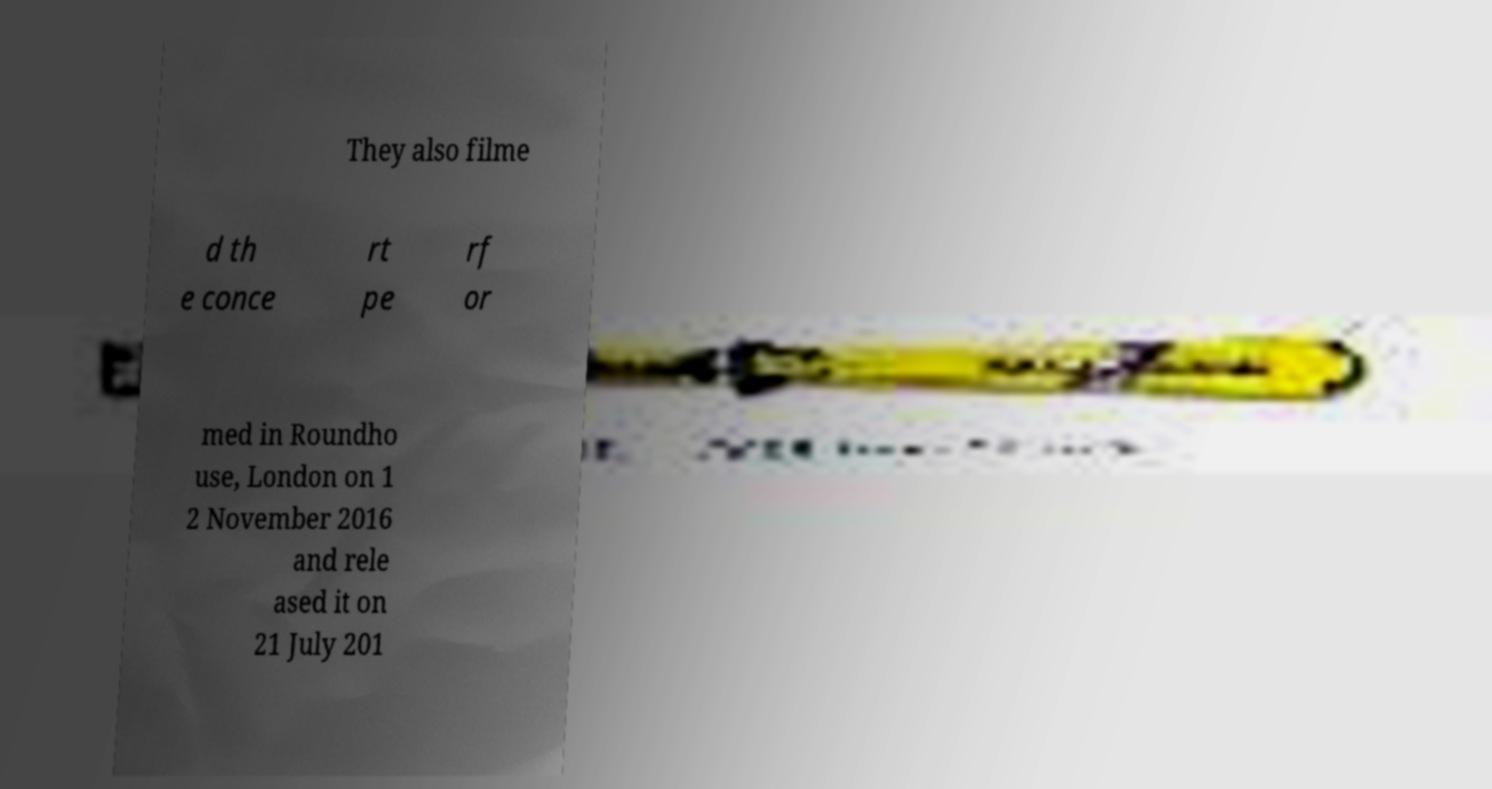Can you accurately transcribe the text from the provided image for me? They also filme d th e conce rt pe rf or med in Roundho use, London on 1 2 November 2016 and rele ased it on 21 July 201 